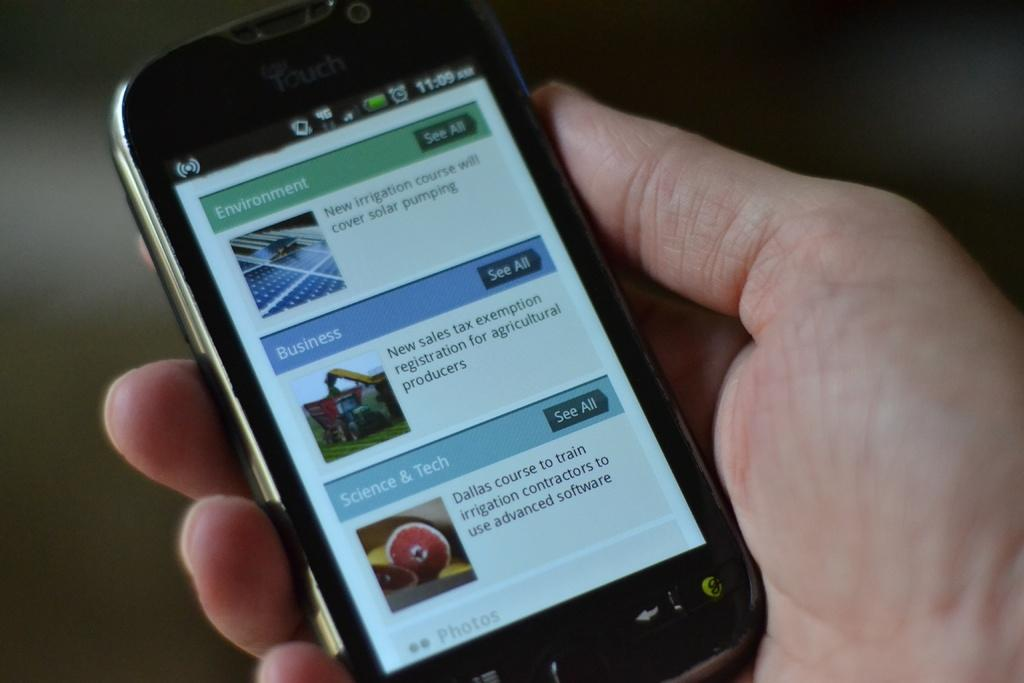<image>
Create a compact narrative representing the image presented. A cell phone shows a page with Environment, business and science headers. 